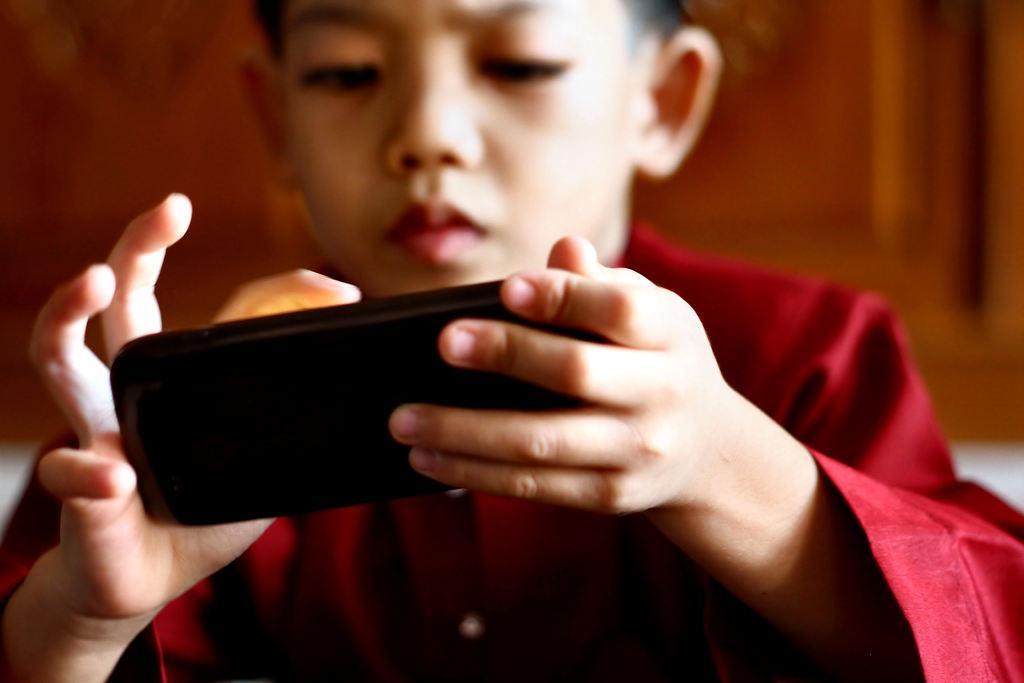In one or two sentences, can you explain what this image depicts? There is a boy in this picture, holding a mobile phone in his hands. He is wearing a red color dress. 